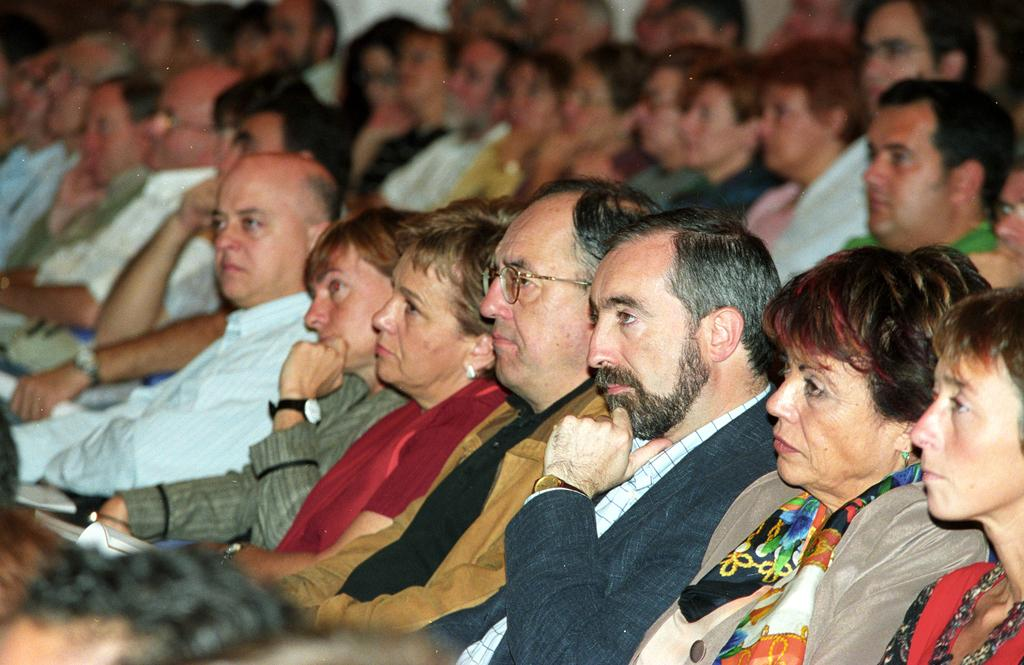How many people are in the image? There is a group of people in the image, but the exact number cannot be determined without more information. Can you describe the group of people in the image? Unfortunately, the provided facts do not give any details about the group of people, so it is impossible to describe them. What type of toothbrush is being used by the person in the image? There is no toothbrush present in the image. Can you hear the person in the image coughing? There is no audio information provided, so it is impossible to determine if anyone is coughing in the image. 